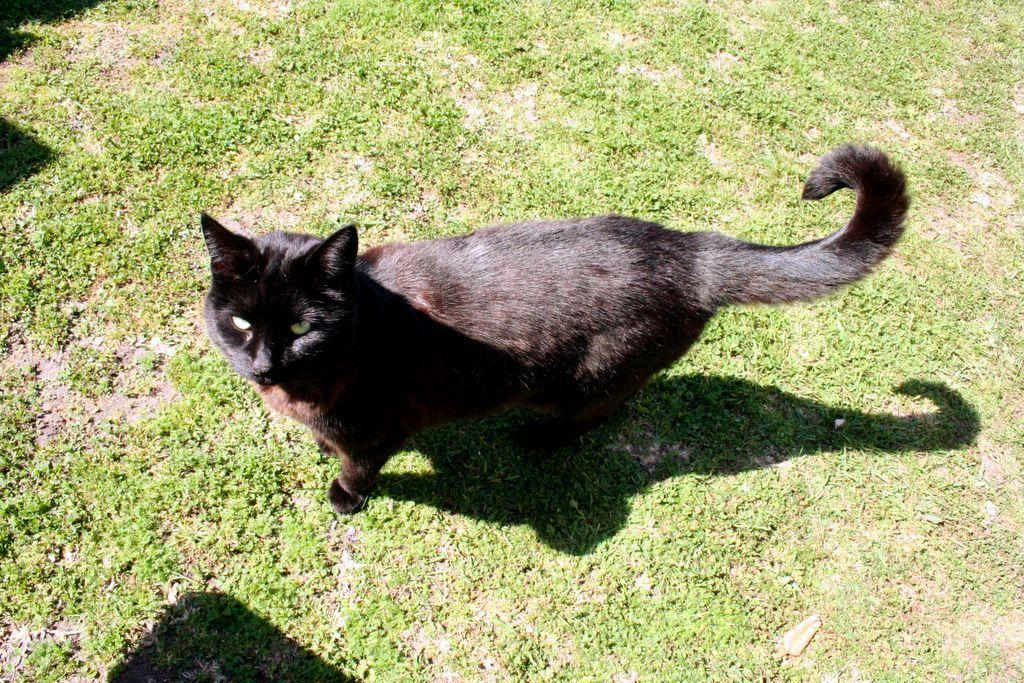What type of animal is present in the image? There is a cat in the image. What is the ground surface like in the image? There is grass on the ground in the image. Where can the receipt for the cat's purchase be found in the image? There is no receipt present in the image, as it only features a cat and grass. 